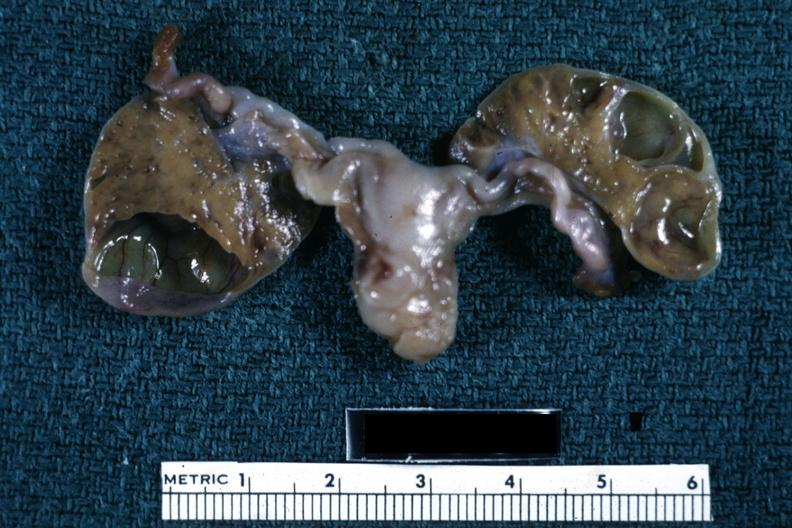where does this belong to?
Answer the question using a single word or phrase. Female reproductive system 